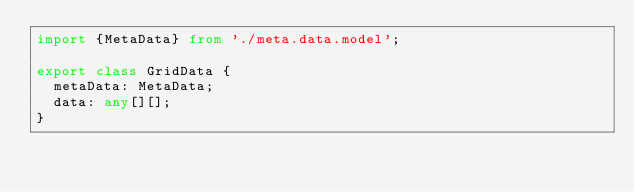Convert code to text. <code><loc_0><loc_0><loc_500><loc_500><_TypeScript_>import {MetaData} from './meta.data.model';

export class GridData {
  metaData: MetaData;
  data: any[][];
}
</code> 